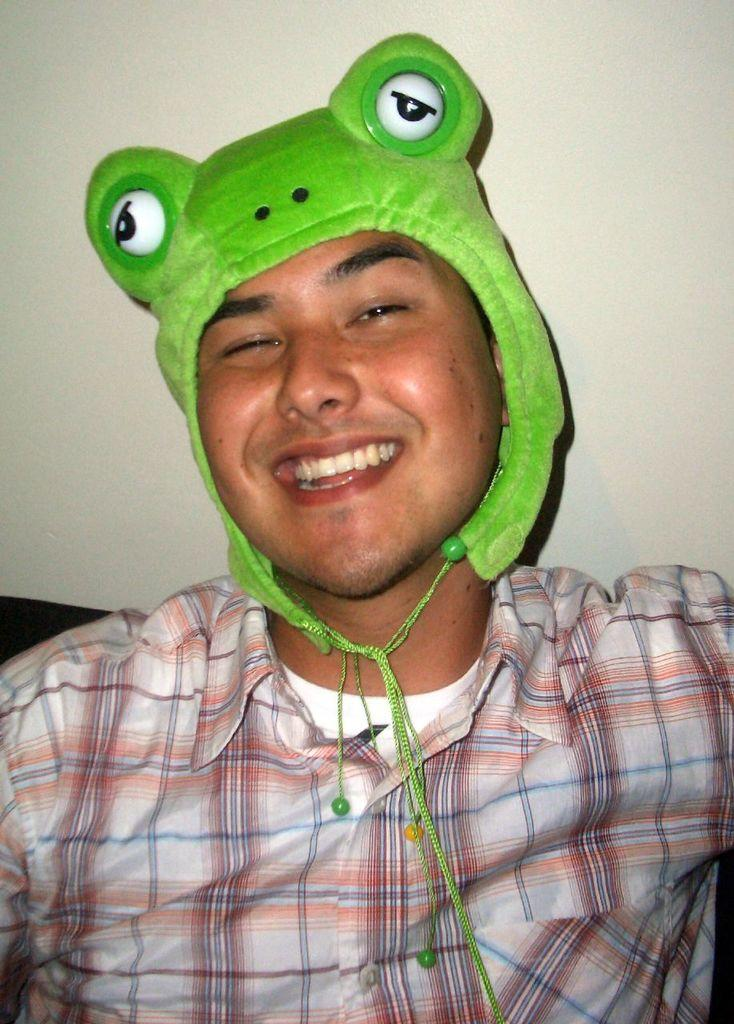What is the main subject of the image? There is a person in the image. What is the person wearing on their head? The person is wearing a cartoon cap. What is the person doing in the image? The person is posing for the picture. What type of committee is visible in the image? There is no committee present in the image; it features a person wearing a cartoon cap and posing for the picture. How many eyes does the person have in the image? The person has two eyes in the image, but this question is irrelevant to the facts provided, as it does not focus on the person's appearance or actions in the image. 